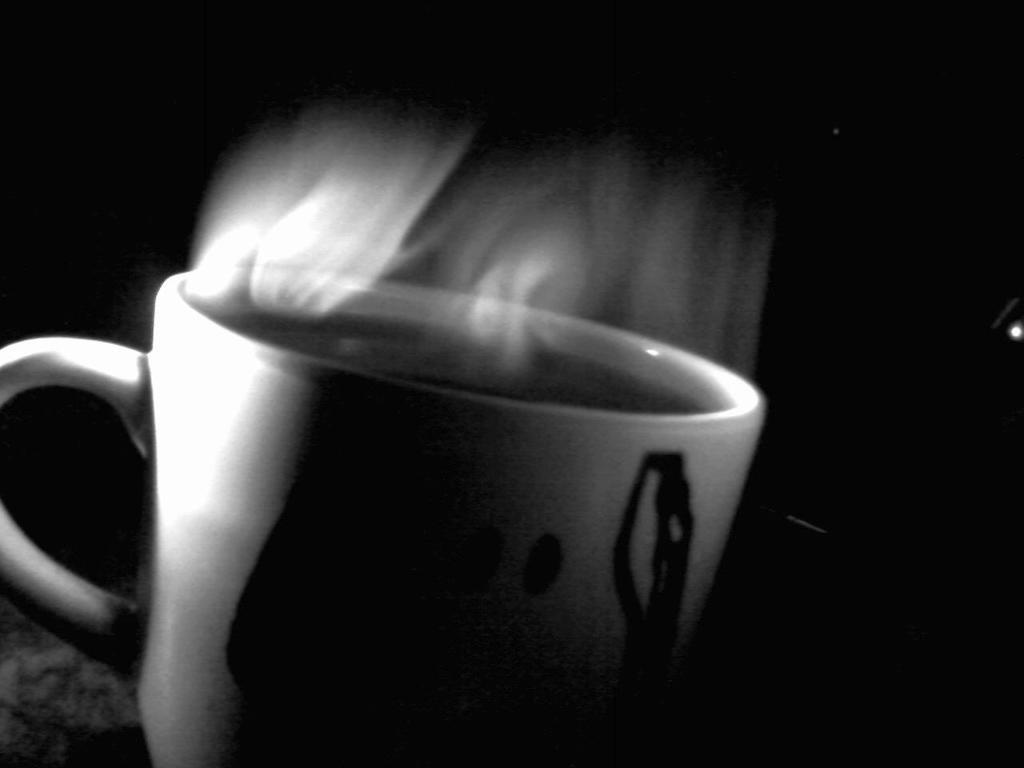What is the color scheme of the image? The image is black and white. What object can be seen in the image? There is a cup in the image. What is inside the cup? The cup contains coffee or tea. What color is the background of the image? The background of the image is black in color. How much salt is present in the cup in the image? There is no salt present in the cup in the image; it contains coffee or tea. What type of vessel is used to transport the cup in the image? The image does not show any vessel used to transport the cup; it only shows the cup itself. 